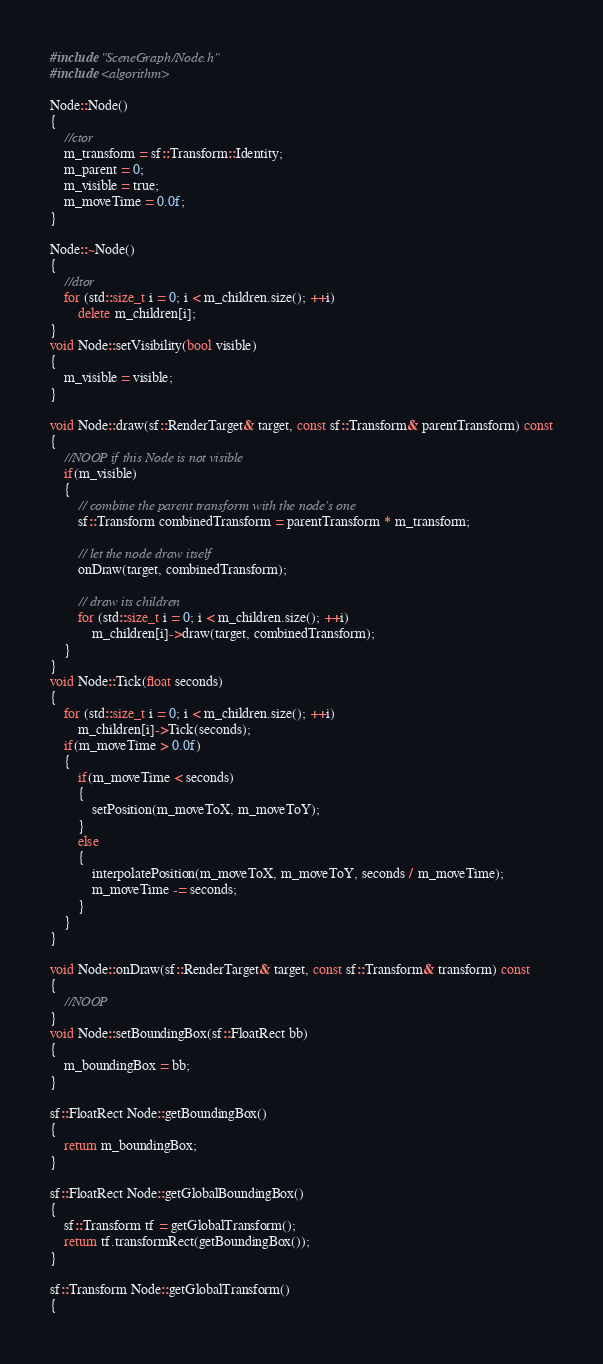<code> <loc_0><loc_0><loc_500><loc_500><_C++_>#include "SceneGraph/Node.h"
#include <algorithm>

Node::Node()
{
    //ctor
    m_transform = sf::Transform::Identity;
    m_parent = 0;
    m_visible = true;
    m_moveTime = 0.0f;
}

Node::~Node()
{
    //dtor
    for (std::size_t i = 0; i < m_children.size(); ++i)
        delete m_children[i];
}
void Node::setVisibility(bool visible)
{
    m_visible = visible;
}

void Node::draw(sf::RenderTarget& target, const sf::Transform& parentTransform) const
{
    //NOOP if this Node is not visible
    if(m_visible)
    {
        // combine the parent transform with the node's one
        sf::Transform combinedTransform = parentTransform * m_transform;

        // let the node draw itself
        onDraw(target, combinedTransform);

        // draw its children
        for (std::size_t i = 0; i < m_children.size(); ++i)
            m_children[i]->draw(target, combinedTransform);
    }
}
void Node::Tick(float seconds)
{
    for (std::size_t i = 0; i < m_children.size(); ++i)
        m_children[i]->Tick(seconds);
    if(m_moveTime > 0.0f)
    {
        if(m_moveTime < seconds)
        {
            setPosition(m_moveToX, m_moveToY);
        }
        else
        {
            interpolatePosition(m_moveToX, m_moveToY, seconds / m_moveTime);
            m_moveTime -= seconds;
        }
    }
}

void Node::onDraw(sf::RenderTarget& target, const sf::Transform& transform) const
{
    //NOOP
}
void Node::setBoundingBox(sf::FloatRect bb)
{
    m_boundingBox = bb;
}

sf::FloatRect Node::getBoundingBox()
{
    return m_boundingBox;
}

sf::FloatRect Node::getGlobalBoundingBox()
{
    sf::Transform tf = getGlobalTransform();
    return tf.transformRect(getBoundingBox());
}

sf::Transform Node::getGlobalTransform()
{</code> 